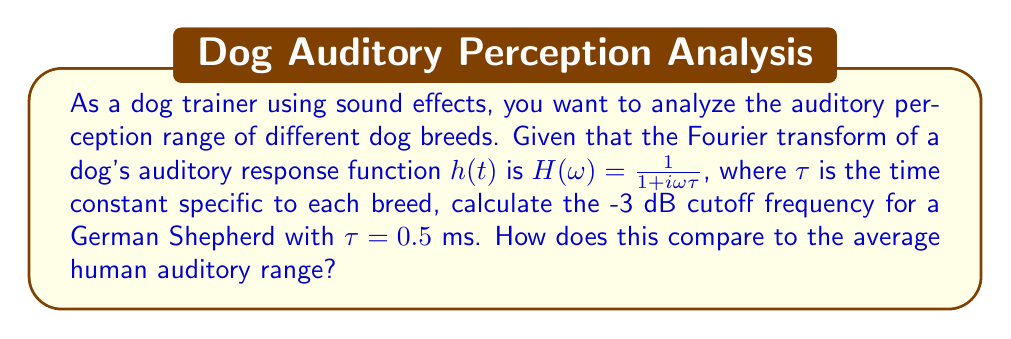What is the answer to this math problem? To solve this problem, we'll follow these steps:

1) The -3 dB cutoff frequency is the frequency at which the magnitude of the frequency response is $\frac{1}{\sqrt{2}}$ of its maximum value.

2) For the given transfer function $H(\omega) = \frac{1}{1 + i\omega\tau}$, we need to find $\omega_c$ such that $|H(\omega_c)| = \frac{1}{\sqrt{2}}$.

3) The magnitude of $H(\omega)$ is given by:

   $$|H(\omega)| = \frac{1}{\sqrt{1 + (\omega\tau)^2}}$$

4) Setting this equal to $\frac{1}{\sqrt{2}}$:

   $$\frac{1}{\sqrt{1 + (\omega_c\tau)^2}} = \frac{1}{\sqrt{2}}$$

5) Solving for $\omega_c$:

   $$1 + (\omega_c\tau)^2 = 2$$
   $$(\omega_c\tau)^2 = 1$$
   $$\omega_c = \frac{1}{\tau}$$

6) For the German Shepherd with $\tau = 0.5$ ms = $5 \times 10^{-4}$ s:

   $$\omega_c = \frac{1}{5 \times 10^{-4}} = 2000 \text{ rad/s}$$

7) Converting to Hz:

   $$f_c = \frac{\omega_c}{2\pi} = \frac{2000}{2\pi} \approx 318.3 \text{ Hz}$$

8) The average human auditory range is typically considered to be 20 Hz to 20 kHz.

9) The calculated cutoff frequency for the German Shepherd (318.3 Hz) falls within the human auditory range but is relatively low, suggesting that the dog can hear lower frequencies more effectively than the average human.
Answer: The -3 dB cutoff frequency for the German Shepherd is approximately 318.3 Hz. This frequency falls within the average human auditory range (20 Hz - 20 kHz) but is closer to the lower end, indicating that the German Shepherd can likely perceive lower frequencies more effectively than the average human. 